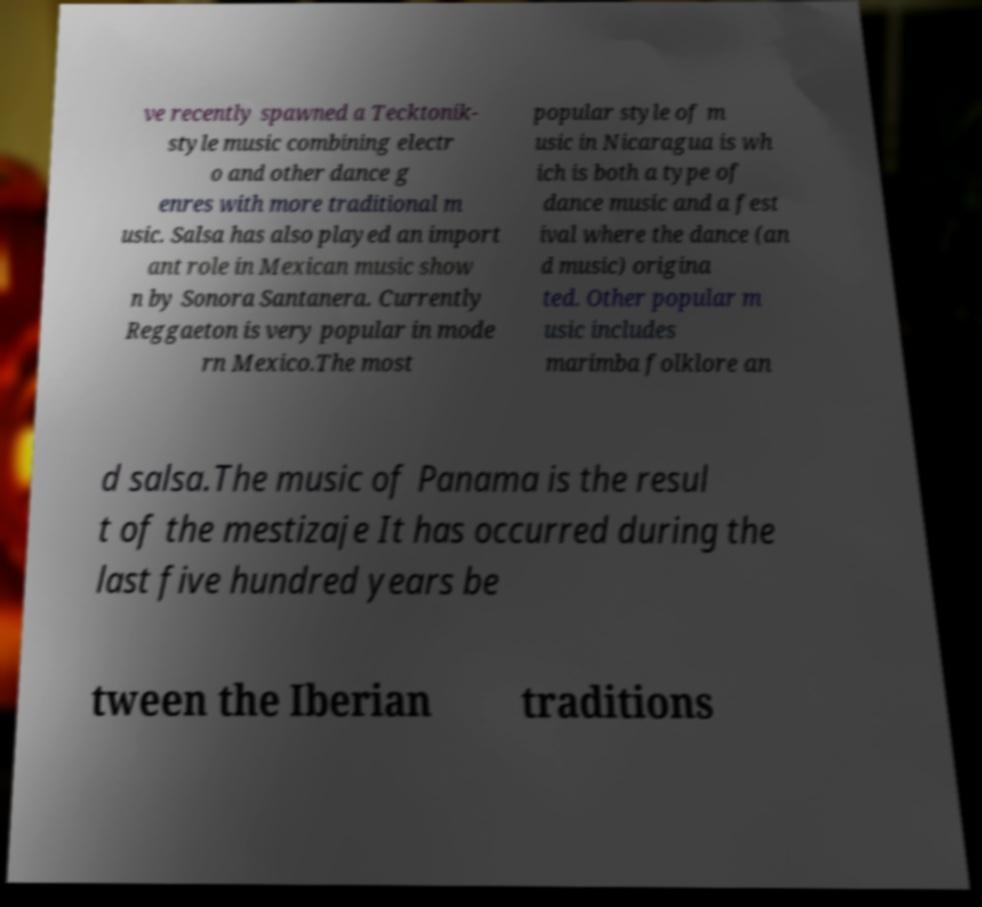Can you accurately transcribe the text from the provided image for me? ve recently spawned a Tecktonik- style music combining electr o and other dance g enres with more traditional m usic. Salsa has also played an import ant role in Mexican music show n by Sonora Santanera. Currently Reggaeton is very popular in mode rn Mexico.The most popular style of m usic in Nicaragua is wh ich is both a type of dance music and a fest ival where the dance (an d music) origina ted. Other popular m usic includes marimba folklore an d salsa.The music of Panama is the resul t of the mestizaje It has occurred during the last five hundred years be tween the Iberian traditions 